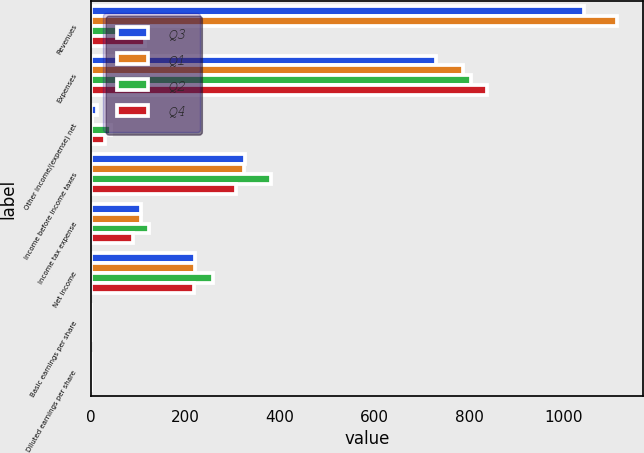<chart> <loc_0><loc_0><loc_500><loc_500><stacked_bar_chart><ecel><fcel>Revenues<fcel>Expenses<fcel>Other income/(expense) net<fcel>Income before income taxes<fcel>Income tax expense<fcel>Net income<fcel>Basic earnings per share<fcel>Diluted earnings per share<nl><fcel>Q3<fcel>1043<fcel>730.3<fcel>12.2<fcel>324.9<fcel>105.1<fcel>219.8<fcel>0.29<fcel>0.29<nl><fcel>Q1<fcel>1113.6<fcel>787.2<fcel>2.6<fcel>323.8<fcel>104.9<fcel>218.9<fcel>0.29<fcel>0.29<nl><fcel>Q2<fcel>113.45<fcel>803.3<fcel>42.8<fcel>379.9<fcel>121.8<fcel>258.1<fcel>0.34<fcel>0.34<nl><fcel>Q4<fcel>113.45<fcel>838<fcel>28.7<fcel>306.5<fcel>89.3<fcel>217.2<fcel>0.28<fcel>0.28<nl></chart> 